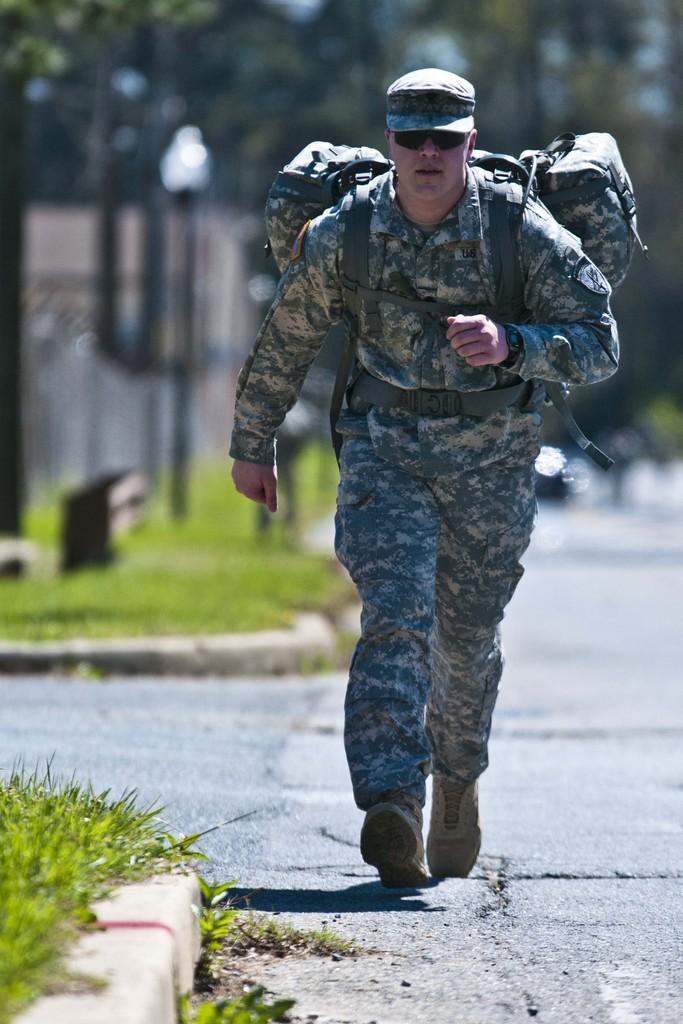In one or two sentences, can you explain what this image depicts? In this image there is one person who is wearing a bag and walking, and at the bottom there is a road and grass and there is a blurry background, but we could see grass and objects. 